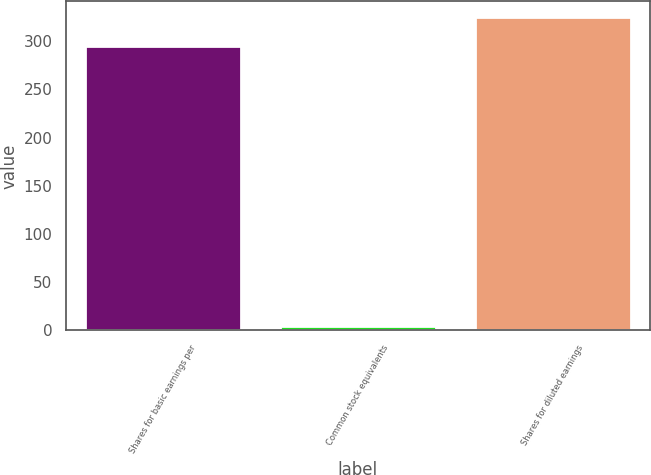Convert chart. <chart><loc_0><loc_0><loc_500><loc_500><bar_chart><fcel>Shares for basic earnings per<fcel>Common stock equivalents<fcel>Shares for diluted earnings<nl><fcel>295.5<fcel>4.1<fcel>325.05<nl></chart> 